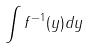<formula> <loc_0><loc_0><loc_500><loc_500>\int f ^ { - 1 } ( y ) d y</formula> 